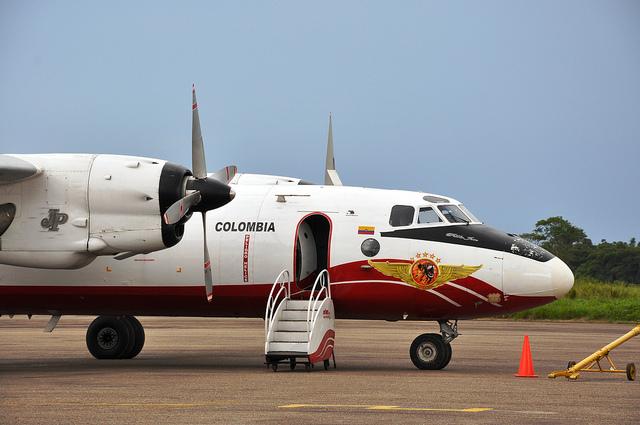How many blades are on the propeller?
Give a very brief answer. 4. What do you call the action that the plane is doing?
Be succinct. Boarding. Where does this plane fly to?
Quick response, please. Columbia. Is anyone boarding the plane?
Be succinct. No. 